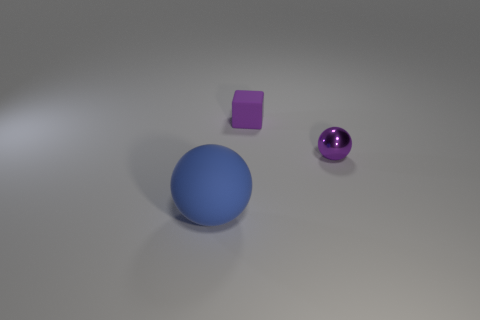Subtract all yellow balls. Subtract all purple cubes. How many balls are left? 2 Add 1 large brown cylinders. How many objects exist? 4 Subtract all balls. How many objects are left? 1 Add 1 small purple metal objects. How many small purple metal objects exist? 2 Subtract 0 yellow cubes. How many objects are left? 3 Subtract all purple shiny things. Subtract all blue objects. How many objects are left? 1 Add 2 large blue spheres. How many large blue spheres are left? 3 